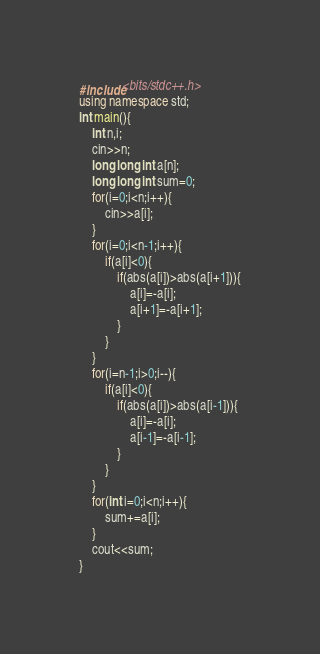<code> <loc_0><loc_0><loc_500><loc_500><_C++_>#include<bits/stdc++.h>
using namespace std;
int main(){
    int n,i;
    cin>>n;
    long long int a[n];
    long long int sum=0;
    for(i=0;i<n;i++){
        cin>>a[i];
    }
    for(i=0;i<n-1;i++){
        if(a[i]<0){
            if(abs(a[i])>abs(a[i+1])){
                a[i]=-a[i];
                a[i+1]=-a[i+1];
            }
        }
    }
    for(i=n-1;i>0;i--){
        if(a[i]<0){
            if(abs(a[i])>abs(a[i-1])){
                a[i]=-a[i];
                a[i-1]=-a[i-1];
            }
        }
    }
    for(int i=0;i<n;i++){
        sum+=a[i];
    }
    cout<<sum;
}</code> 